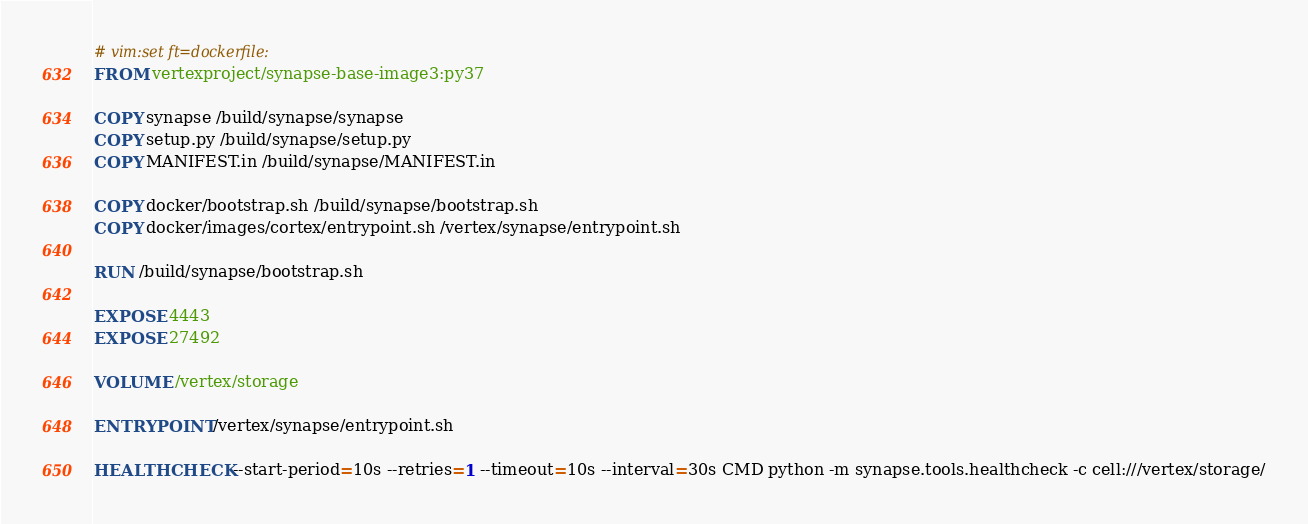<code> <loc_0><loc_0><loc_500><loc_500><_Dockerfile_># vim:set ft=dockerfile:
FROM vertexproject/synapse-base-image3:py37

COPY synapse /build/synapse/synapse
COPY setup.py /build/synapse/setup.py
COPY MANIFEST.in /build/synapse/MANIFEST.in

COPY docker/bootstrap.sh /build/synapse/bootstrap.sh
COPY docker/images/cortex/entrypoint.sh /vertex/synapse/entrypoint.sh

RUN /build/synapse/bootstrap.sh

EXPOSE 4443
EXPOSE 27492

VOLUME /vertex/storage

ENTRYPOINT /vertex/synapse/entrypoint.sh

HEALTHCHECK --start-period=10s --retries=1 --timeout=10s --interval=30s CMD python -m synapse.tools.healthcheck -c cell:///vertex/storage/
</code> 